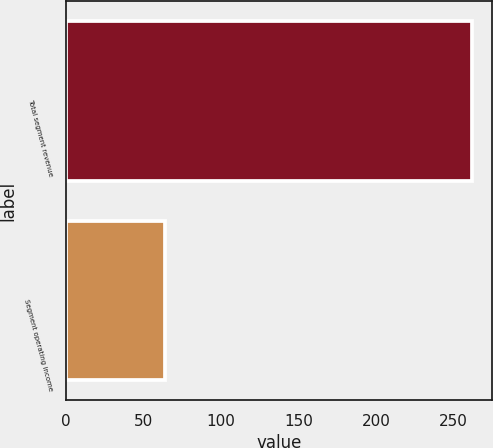<chart> <loc_0><loc_0><loc_500><loc_500><bar_chart><fcel>Total segment revenue<fcel>Segment operating income<nl><fcel>262<fcel>64<nl></chart> 